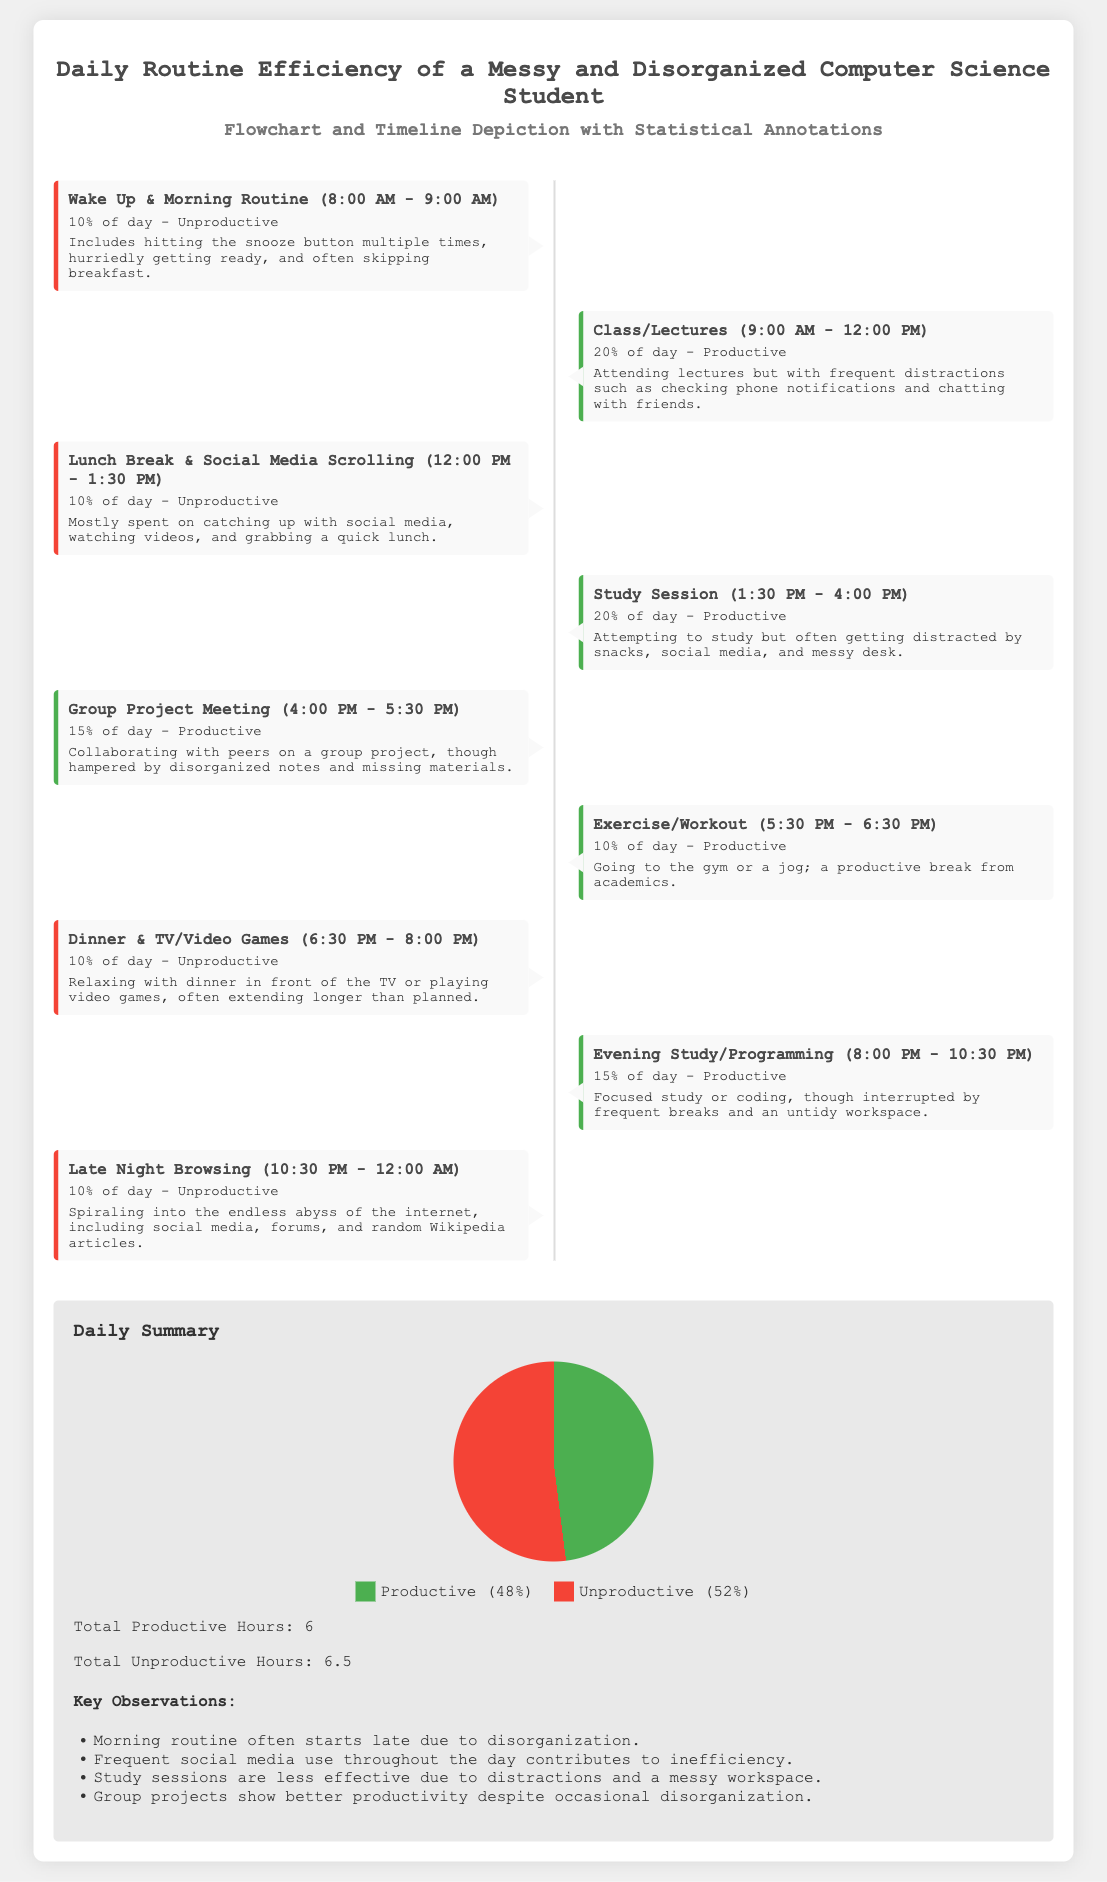What is the percentage of productive time spent? The productive time is represented in the daily summary, and it shows 48% of the day spent on productive activities.
Answer: 48% What activity takes place from 4:00 PM to 5:30 PM? This time block is dedicated to a group project meeting, as outlined in the timeline.
Answer: Group Project Meeting How many productive hours are recorded in the daily routine? The document states a total of 6 productive hours are spent throughout the day.
Answer: 6 What occupies the time slot from 10:30 PM to 12:00 AM? The last time block before midnight is spent on late night browsing activities, as indicated.
Answer: Late Night Browsing What is the total unproductive hours mentioned? According to the daily summary, the total unproductive hours equal 6.5 hours.
Answer: 6.5 What is the primary reason for morning routine's inefficiency? The document lists disorganization as the main reason causing inefficiencies during the morning routine.
Answer: Disorganization What percentage of the day is spent on unproductive activities? The infographic indicates that 52% of the day is characterized by unproductive activities.
Answer: 52% What is highlighted as a key observation about study sessions? The key observation mentions that distractions and a messy workspace hinder the effectiveness of study sessions.
Answer: Distractions and messy workspace Which color represents productive activities in the circular chart? The color green is used in the chart to represent productive activities.
Answer: Green 